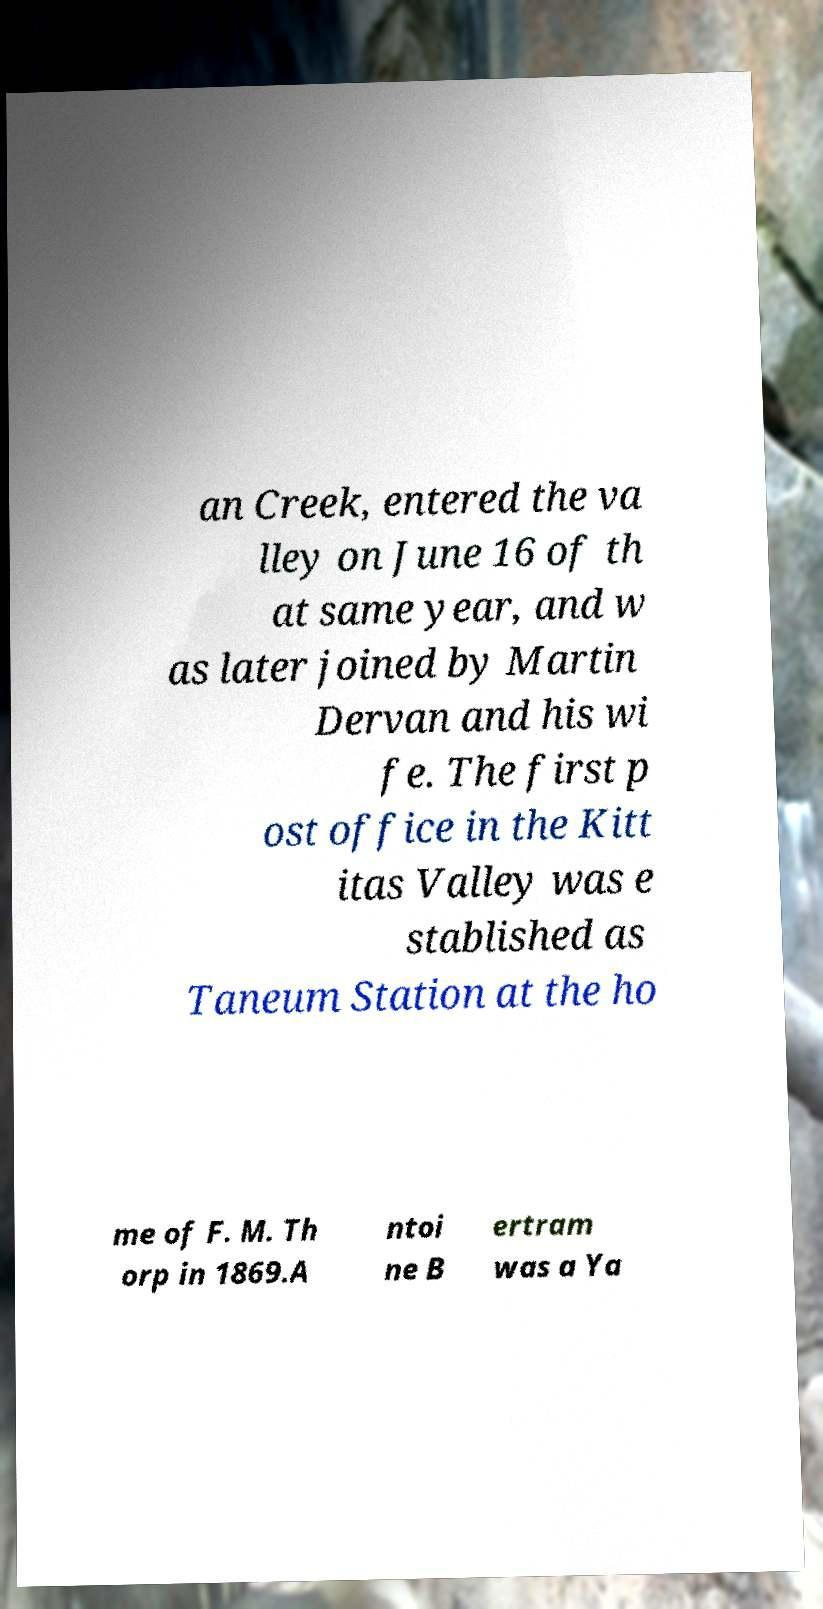What messages or text are displayed in this image? I need them in a readable, typed format. an Creek, entered the va lley on June 16 of th at same year, and w as later joined by Martin Dervan and his wi fe. The first p ost office in the Kitt itas Valley was e stablished as Taneum Station at the ho me of F. M. Th orp in 1869.A ntoi ne B ertram was a Ya 